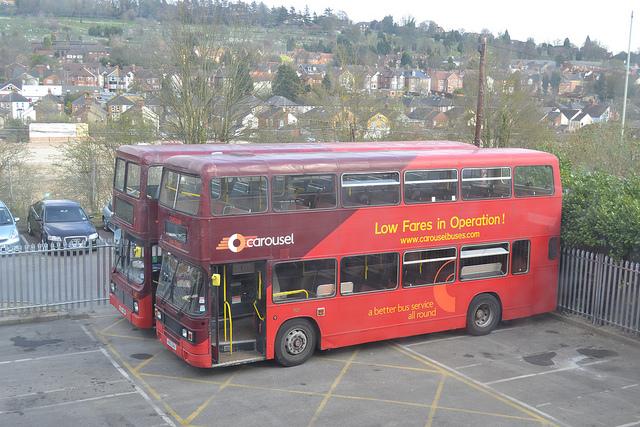Does the bus have 2 levels?
Be succinct. Yes. Is this a food truck?
Short answer required. No. Is this a parking lot for buses?
Quick response, please. Yes. How much does it cost to ride this bus?
Short answer required. Low fares. 